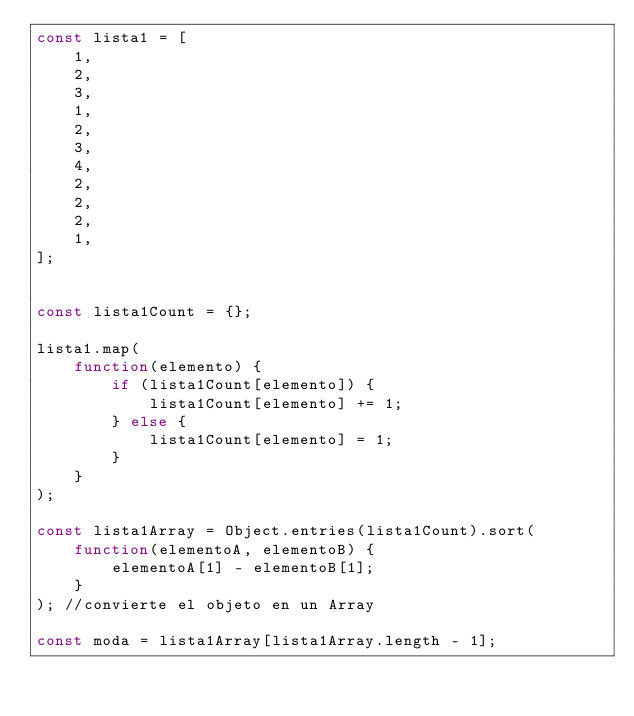Convert code to text. <code><loc_0><loc_0><loc_500><loc_500><_JavaScript_>const lista1 = [
    1,
    2,
    3,
    1,
    2,
    3,
    4,
    2,
    2,
    2,
    1,
];


const lista1Count = {};

lista1.map(
    function(elemento) {
        if (lista1Count[elemento]) {
            lista1Count[elemento] += 1;
        } else {
            lista1Count[elemento] = 1;
        }
    }
);

const lista1Array = Object.entries(lista1Count).sort(
    function(elementoA, elementoB) {
        elementoA[1] - elementoB[1];
    }
); //convierte el objeto en un Array

const moda = lista1Array[lista1Array.length - 1];</code> 